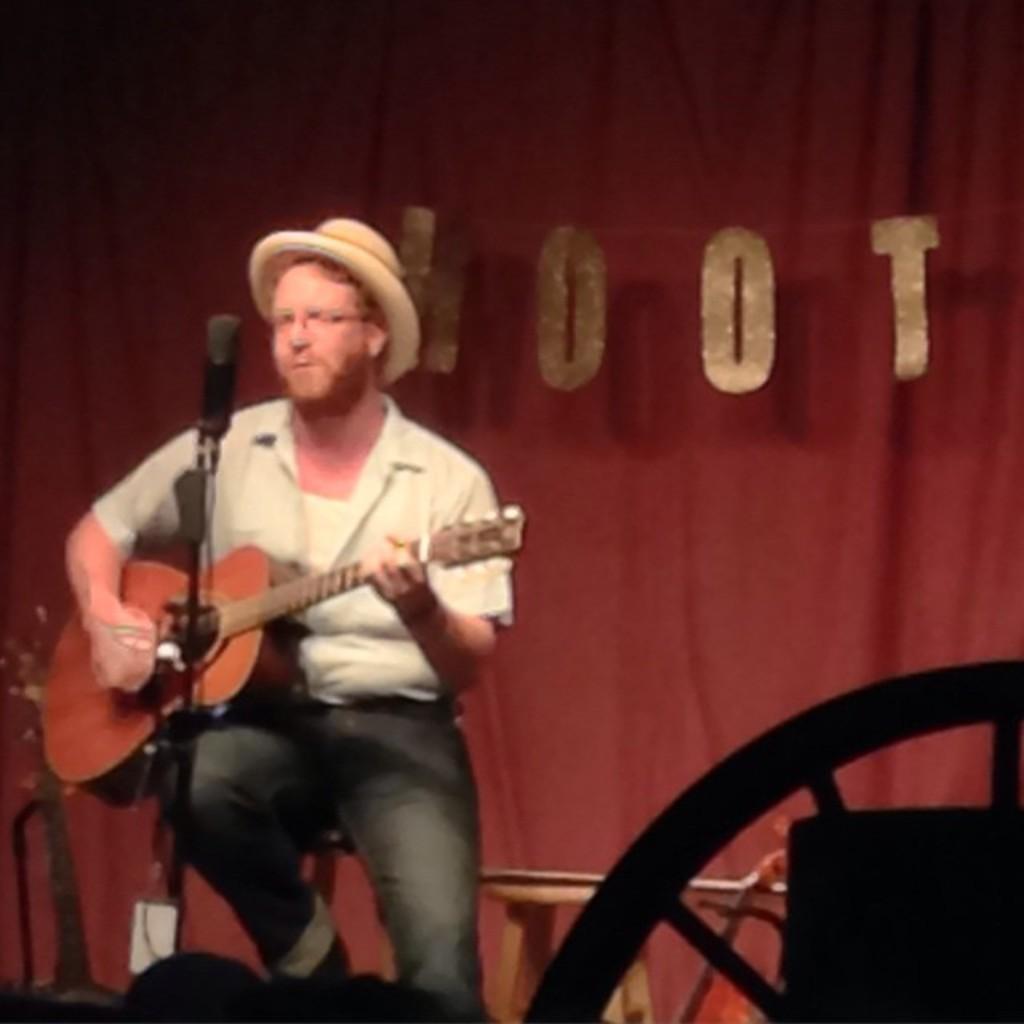How would you summarize this image in a sentence or two? In this picture there is a man who is sitting on the chair and there is a mic in front of him and his holding the guitar in his hand, it seems to be a music event and he is wearing a hat. 